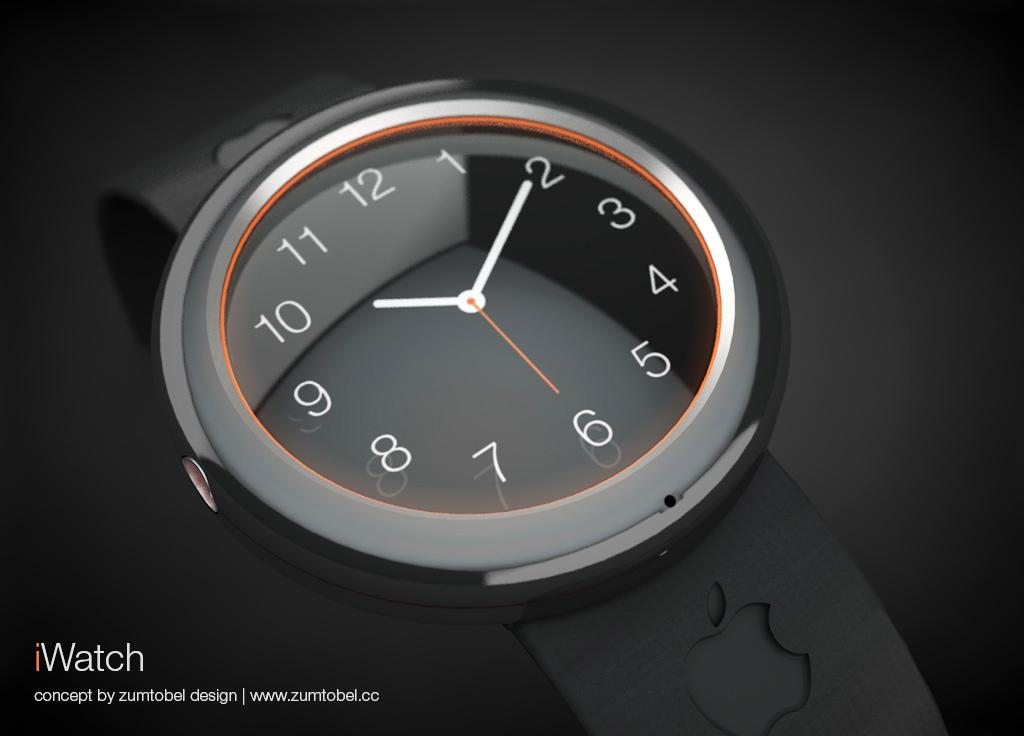Provide a one-sentence caption for the provided image. A photo of a black watch that is labeled I Watch. 